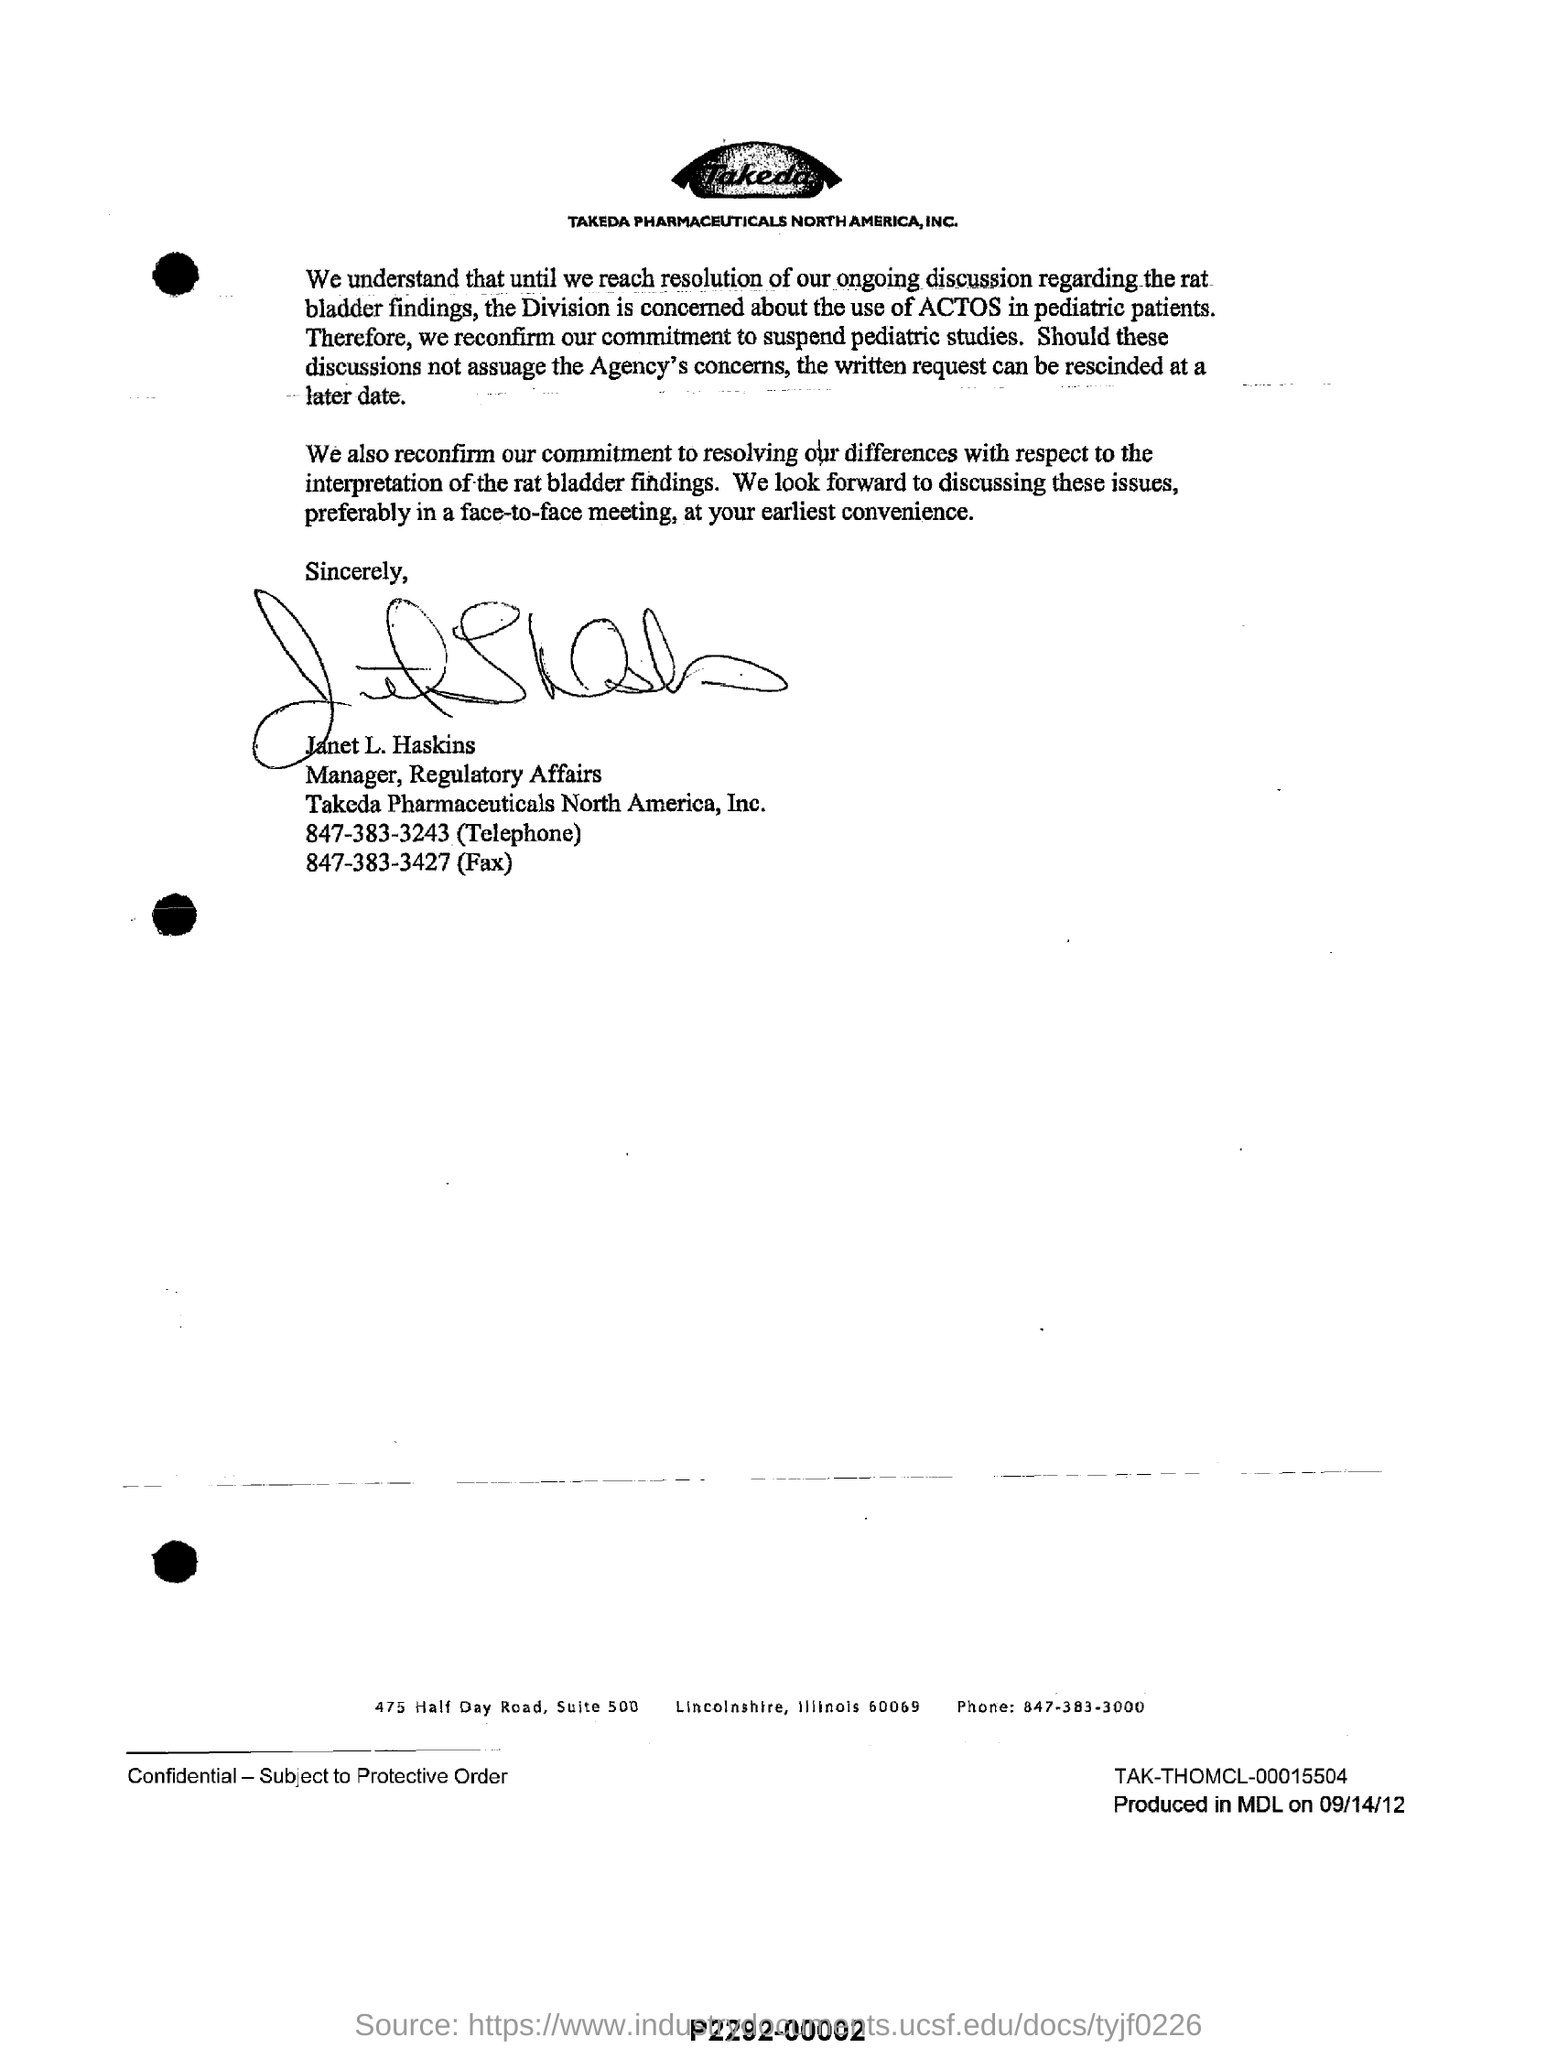What is written in the image?
Keep it short and to the point. Takeda. Which pharmaceutical company is mentioned in the document?
Make the answer very short. Takeda. What is Fax number of 'Takeda Pharmaceuticals' ?
Offer a very short reply. 847-383-3427. 